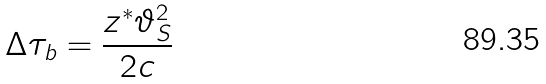<formula> <loc_0><loc_0><loc_500><loc_500>\Delta \tau _ { b } = \frac { z ^ { * } \vartheta _ { S } ^ { 2 } } { 2 c }</formula> 